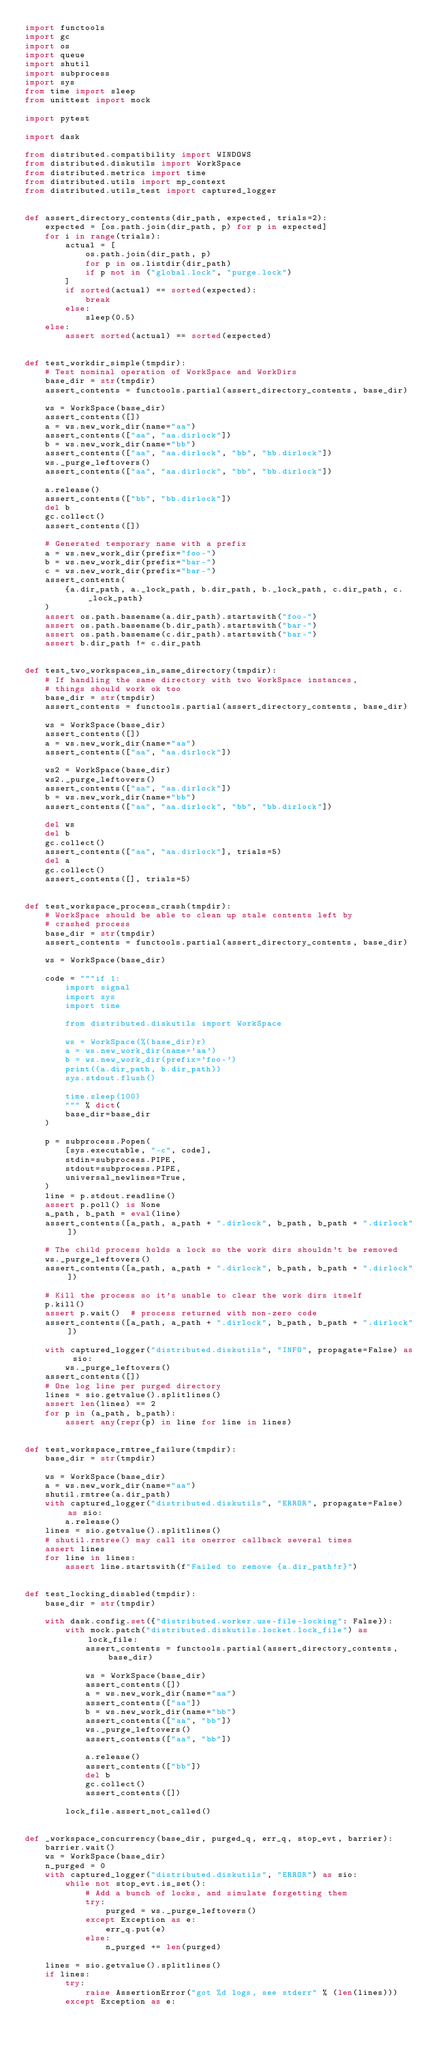<code> <loc_0><loc_0><loc_500><loc_500><_Python_>import functools
import gc
import os
import queue
import shutil
import subprocess
import sys
from time import sleep
from unittest import mock

import pytest

import dask

from distributed.compatibility import WINDOWS
from distributed.diskutils import WorkSpace
from distributed.metrics import time
from distributed.utils import mp_context
from distributed.utils_test import captured_logger


def assert_directory_contents(dir_path, expected, trials=2):
    expected = [os.path.join(dir_path, p) for p in expected]
    for i in range(trials):
        actual = [
            os.path.join(dir_path, p)
            for p in os.listdir(dir_path)
            if p not in ("global.lock", "purge.lock")
        ]
        if sorted(actual) == sorted(expected):
            break
        else:
            sleep(0.5)
    else:
        assert sorted(actual) == sorted(expected)


def test_workdir_simple(tmpdir):
    # Test nominal operation of WorkSpace and WorkDirs
    base_dir = str(tmpdir)
    assert_contents = functools.partial(assert_directory_contents, base_dir)

    ws = WorkSpace(base_dir)
    assert_contents([])
    a = ws.new_work_dir(name="aa")
    assert_contents(["aa", "aa.dirlock"])
    b = ws.new_work_dir(name="bb")
    assert_contents(["aa", "aa.dirlock", "bb", "bb.dirlock"])
    ws._purge_leftovers()
    assert_contents(["aa", "aa.dirlock", "bb", "bb.dirlock"])

    a.release()
    assert_contents(["bb", "bb.dirlock"])
    del b
    gc.collect()
    assert_contents([])

    # Generated temporary name with a prefix
    a = ws.new_work_dir(prefix="foo-")
    b = ws.new_work_dir(prefix="bar-")
    c = ws.new_work_dir(prefix="bar-")
    assert_contents(
        {a.dir_path, a._lock_path, b.dir_path, b._lock_path, c.dir_path, c._lock_path}
    )
    assert os.path.basename(a.dir_path).startswith("foo-")
    assert os.path.basename(b.dir_path).startswith("bar-")
    assert os.path.basename(c.dir_path).startswith("bar-")
    assert b.dir_path != c.dir_path


def test_two_workspaces_in_same_directory(tmpdir):
    # If handling the same directory with two WorkSpace instances,
    # things should work ok too
    base_dir = str(tmpdir)
    assert_contents = functools.partial(assert_directory_contents, base_dir)

    ws = WorkSpace(base_dir)
    assert_contents([])
    a = ws.new_work_dir(name="aa")
    assert_contents(["aa", "aa.dirlock"])

    ws2 = WorkSpace(base_dir)
    ws2._purge_leftovers()
    assert_contents(["aa", "aa.dirlock"])
    b = ws.new_work_dir(name="bb")
    assert_contents(["aa", "aa.dirlock", "bb", "bb.dirlock"])

    del ws
    del b
    gc.collect()
    assert_contents(["aa", "aa.dirlock"], trials=5)
    del a
    gc.collect()
    assert_contents([], trials=5)


def test_workspace_process_crash(tmpdir):
    # WorkSpace should be able to clean up stale contents left by
    # crashed process
    base_dir = str(tmpdir)
    assert_contents = functools.partial(assert_directory_contents, base_dir)

    ws = WorkSpace(base_dir)

    code = """if 1:
        import signal
        import sys
        import time

        from distributed.diskutils import WorkSpace

        ws = WorkSpace(%(base_dir)r)
        a = ws.new_work_dir(name='aa')
        b = ws.new_work_dir(prefix='foo-')
        print((a.dir_path, b.dir_path))
        sys.stdout.flush()

        time.sleep(100)
        """ % dict(
        base_dir=base_dir
    )

    p = subprocess.Popen(
        [sys.executable, "-c", code],
        stdin=subprocess.PIPE,
        stdout=subprocess.PIPE,
        universal_newlines=True,
    )
    line = p.stdout.readline()
    assert p.poll() is None
    a_path, b_path = eval(line)
    assert_contents([a_path, a_path + ".dirlock", b_path, b_path + ".dirlock"])

    # The child process holds a lock so the work dirs shouldn't be removed
    ws._purge_leftovers()
    assert_contents([a_path, a_path + ".dirlock", b_path, b_path + ".dirlock"])

    # Kill the process so it's unable to clear the work dirs itself
    p.kill()
    assert p.wait()  # process returned with non-zero code
    assert_contents([a_path, a_path + ".dirlock", b_path, b_path + ".dirlock"])

    with captured_logger("distributed.diskutils", "INFO", propagate=False) as sio:
        ws._purge_leftovers()
    assert_contents([])
    # One log line per purged directory
    lines = sio.getvalue().splitlines()
    assert len(lines) == 2
    for p in (a_path, b_path):
        assert any(repr(p) in line for line in lines)


def test_workspace_rmtree_failure(tmpdir):
    base_dir = str(tmpdir)

    ws = WorkSpace(base_dir)
    a = ws.new_work_dir(name="aa")
    shutil.rmtree(a.dir_path)
    with captured_logger("distributed.diskutils", "ERROR", propagate=False) as sio:
        a.release()
    lines = sio.getvalue().splitlines()
    # shutil.rmtree() may call its onerror callback several times
    assert lines
    for line in lines:
        assert line.startswith(f"Failed to remove {a.dir_path!r}")


def test_locking_disabled(tmpdir):
    base_dir = str(tmpdir)

    with dask.config.set({"distributed.worker.use-file-locking": False}):
        with mock.patch("distributed.diskutils.locket.lock_file") as lock_file:
            assert_contents = functools.partial(assert_directory_contents, base_dir)

            ws = WorkSpace(base_dir)
            assert_contents([])
            a = ws.new_work_dir(name="aa")
            assert_contents(["aa"])
            b = ws.new_work_dir(name="bb")
            assert_contents(["aa", "bb"])
            ws._purge_leftovers()
            assert_contents(["aa", "bb"])

            a.release()
            assert_contents(["bb"])
            del b
            gc.collect()
            assert_contents([])

        lock_file.assert_not_called()


def _workspace_concurrency(base_dir, purged_q, err_q, stop_evt, barrier):
    barrier.wait()
    ws = WorkSpace(base_dir)
    n_purged = 0
    with captured_logger("distributed.diskutils", "ERROR") as sio:
        while not stop_evt.is_set():
            # Add a bunch of locks, and simulate forgetting them
            try:
                purged = ws._purge_leftovers()
            except Exception as e:
                err_q.put(e)
            else:
                n_purged += len(purged)

    lines = sio.getvalue().splitlines()
    if lines:
        try:
            raise AssertionError("got %d logs, see stderr" % (len(lines)))
        except Exception as e:</code> 